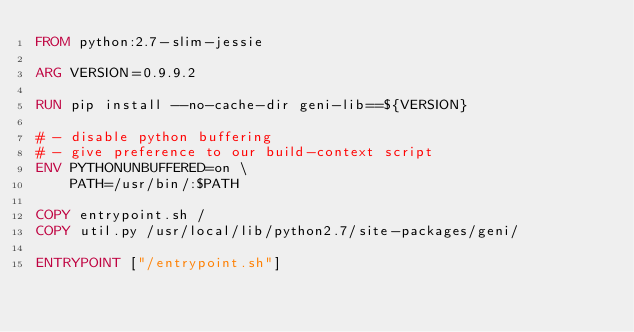Convert code to text. <code><loc_0><loc_0><loc_500><loc_500><_Dockerfile_>FROM python:2.7-slim-jessie

ARG VERSION=0.9.9.2

RUN pip install --no-cache-dir geni-lib==${VERSION}

# - disable python buffering
# - give preference to our build-context script
ENV PYTHONUNBUFFERED=on \
    PATH=/usr/bin/:$PATH

COPY entrypoint.sh /
COPY util.py /usr/local/lib/python2.7/site-packages/geni/

ENTRYPOINT ["/entrypoint.sh"]
</code> 